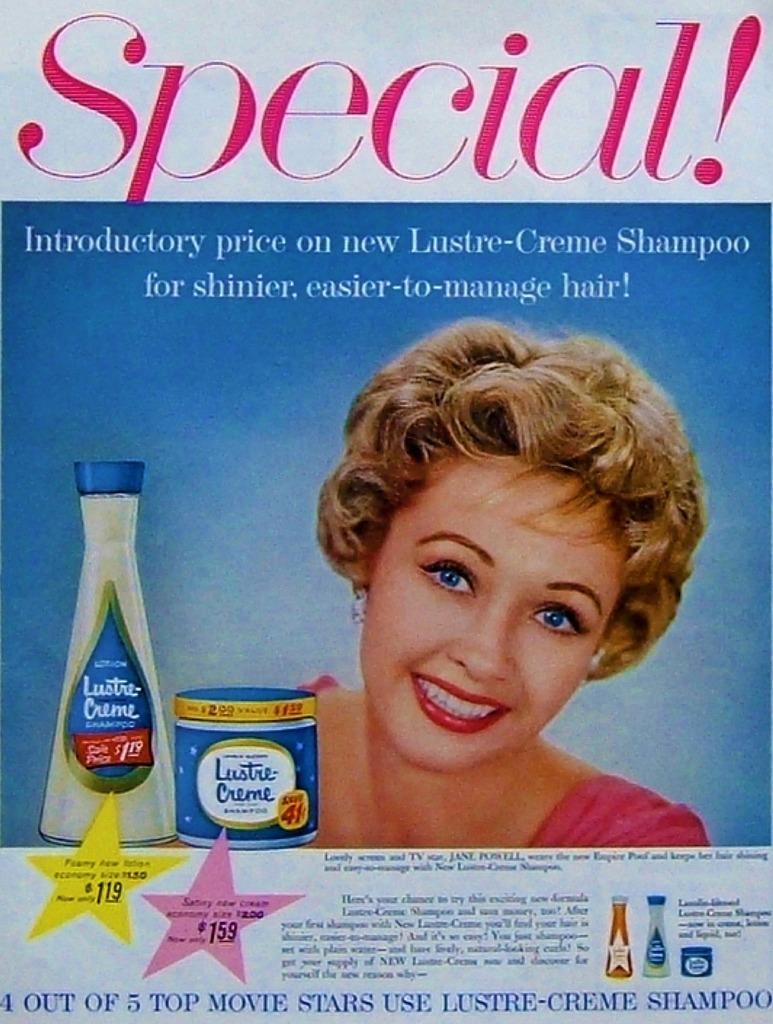What written in red at the top?
Your answer should be very brief. Special!. 